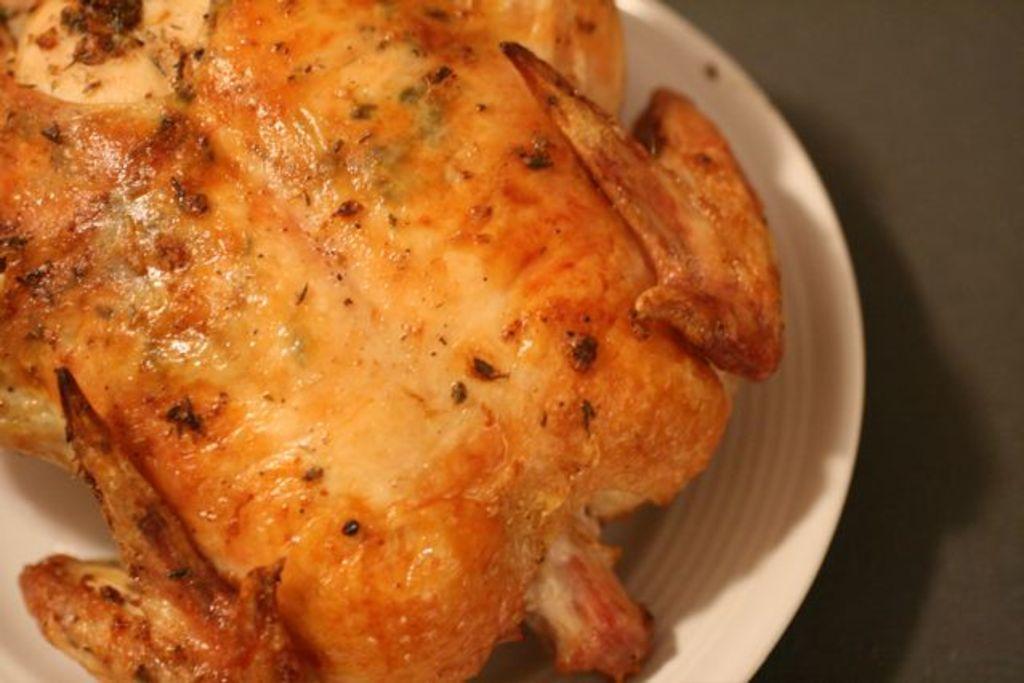Describe this image in one or two sentences. In this image we can see roasted chicken piece which is in white color plate. 